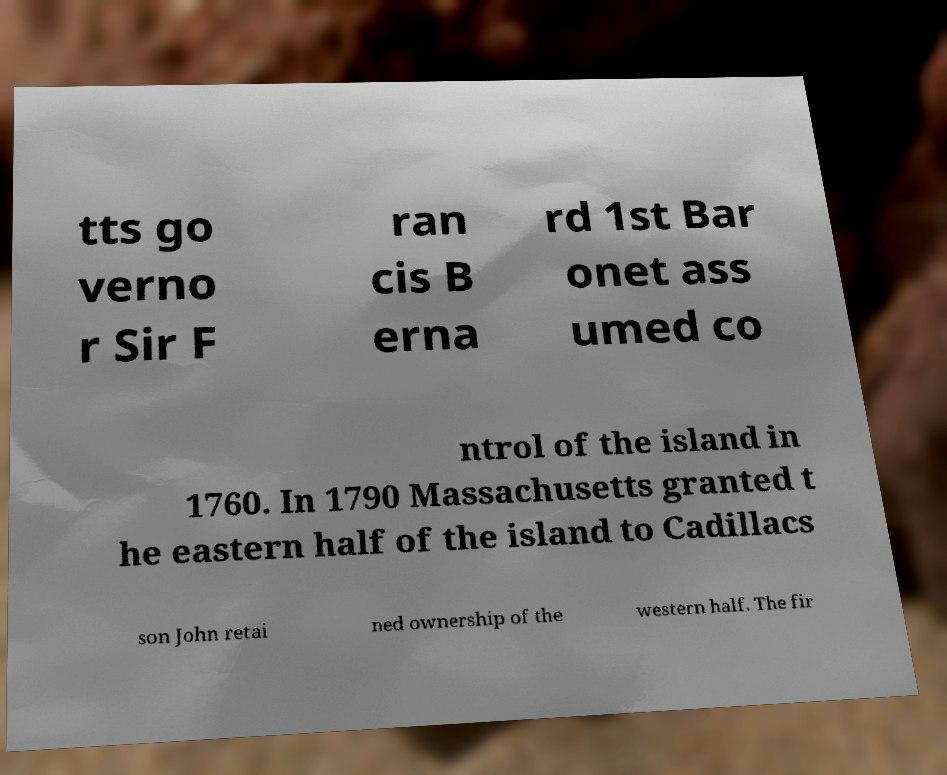What messages or text are displayed in this image? I need them in a readable, typed format. tts go verno r Sir F ran cis B erna rd 1st Bar onet ass umed co ntrol of the island in 1760. In 1790 Massachusetts granted t he eastern half of the island to Cadillacs son John retai ned ownership of the western half. The fir 